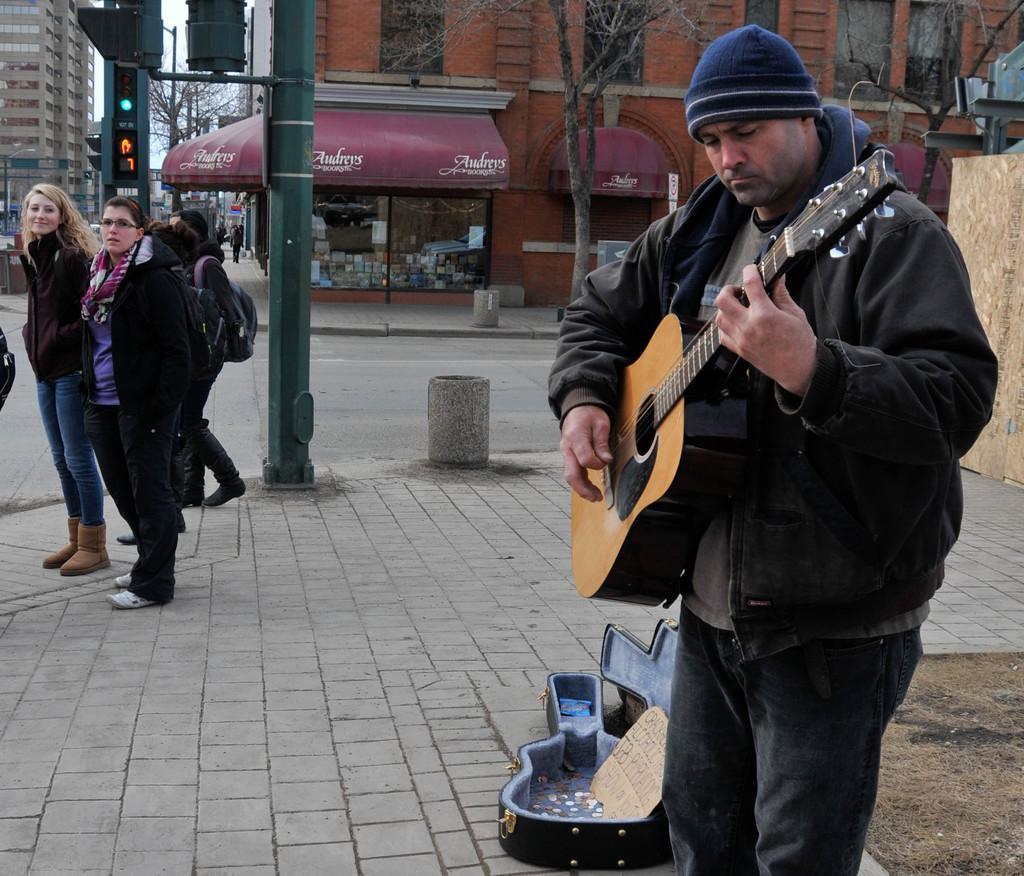Please provide a concise description of this image. This image is taken in outdoors. There are few people standing on the sidewalk in this image. In the right side of the image a man is standing, holding a guitar in his hands and playing the music, beside him there is a guitar box with few coins in it. In the left side of the image few people are standing. In the middle of the image there is a pole with signal lights. In the background there are two buildings with windows and there are few trees at the background. 